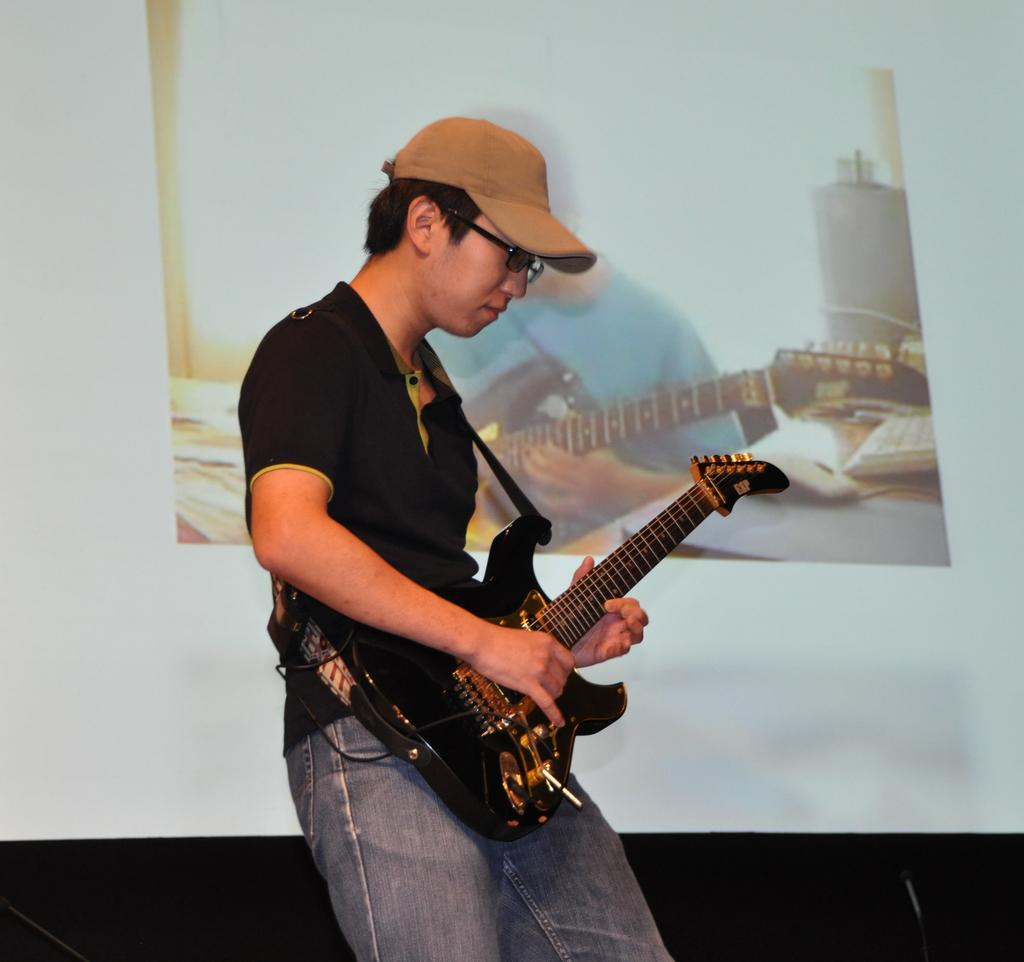What is the man in the image doing? The man is playing a guitar. How is the man positioned in the image? The man is standing. What is on the wall in the image? There is a poster on the wall in the image. What type of headwear is the man wearing? The man is wearing a cap. What type of eyewear is the man wearing? The man is wearing goggles. What type of clock is visible on the man's wrist in the image? There is no clock visible on the man's wrist in the image. What type of pen is the man using to write on the poster in the image? There is no pen visible in the image, and the man is not writing on the poster. 